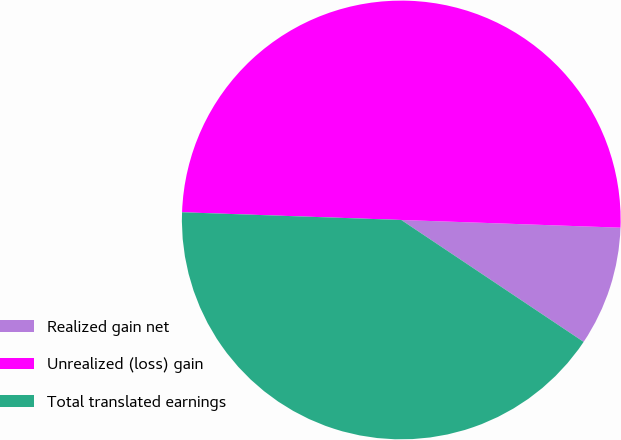Convert chart. <chart><loc_0><loc_0><loc_500><loc_500><pie_chart><fcel>Realized gain net<fcel>Unrealized (loss) gain<fcel>Total translated earnings<nl><fcel>8.82%<fcel>50.0%<fcel>41.18%<nl></chart> 